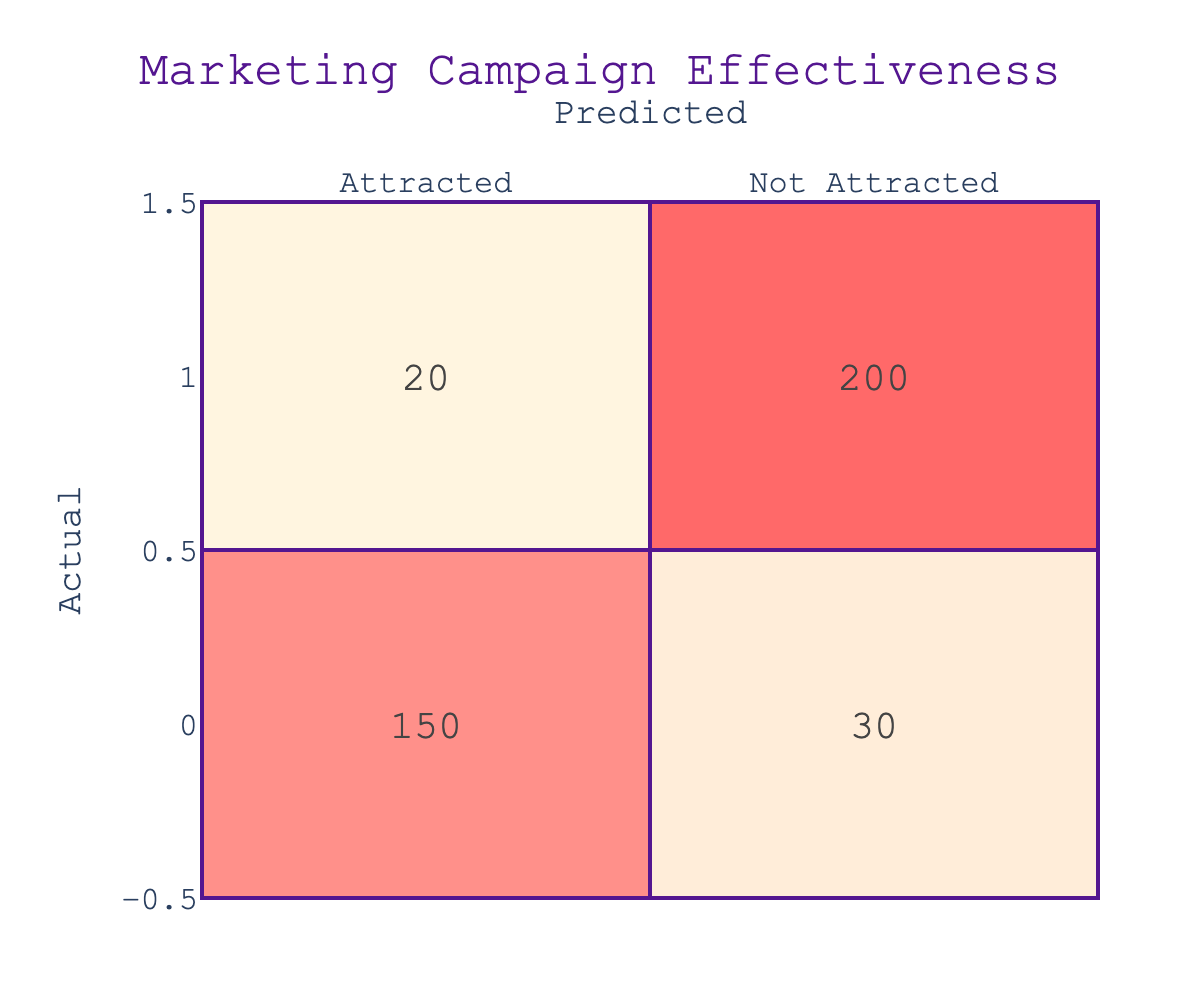What is the number of collectors attracted by the marketing campaign? To find this, we look at the "Attracted" row under the "Attracted" column. The value is 150.
Answer: 150 What is the total number of collectors who were not attracted by the marketing campaign? We locate the "Not Attracted" row and sum the values in that row, which are 20 (Predicted Attracted) + 200 (Predicted Not Attracted) = 220.
Answer: 220 How many collectors were predicted to be attracted but were actually not? We check the "Not Attracted" row under the "Attracted" column, where the value is 30.
Answer: 30 What is the total number of collectors who were attracted, regardless of prediction? We consider the "Attracted" row, summing values: 150 (Predicted Attracted) + 30 (Not Predicted but Attracted) = 180.
Answer: 180 What percentage of the total collectors were accurately predicted to be attracted? We first sum the total number of predicted proportions, which is 150 + 30 + 20 + 200 = 400. Then, we calculate the percentage of accurately predicted attracted collectors as (150/400)*100 = 37.5%.
Answer: 37.5% Is it true that the marketing campaign attracted more collectors than it missed? Comparing values, attracted collectors (150) versus missed collectors (30 + 20 = 50), we see that 150 > 50, thus the statement is true.
Answer: Yes Which group of actual collectors had the highest number according to the marketing predictions? We look at the totals: 150 attracted and 200 not attracted. The "Not Attracted" group has the highest number (200).
Answer: Not Attracted What is the accuracy rate of the marketing campaign's predictions overall? To find the accuracy rate, we calculate the number of true positives (150) and true negatives (200) and add them: 150 + 200 = 350. We then divide by the total number of predictions (400): 350/400 = 0.875 or 87.5%.
Answer: 87.5% If we add the true negatives and false positives together, what will be the result? True negatives are 200 and false positives are 30 (those predicted attracted but not). Therefore, the sum is 200 + 30 = 230.
Answer: 230 